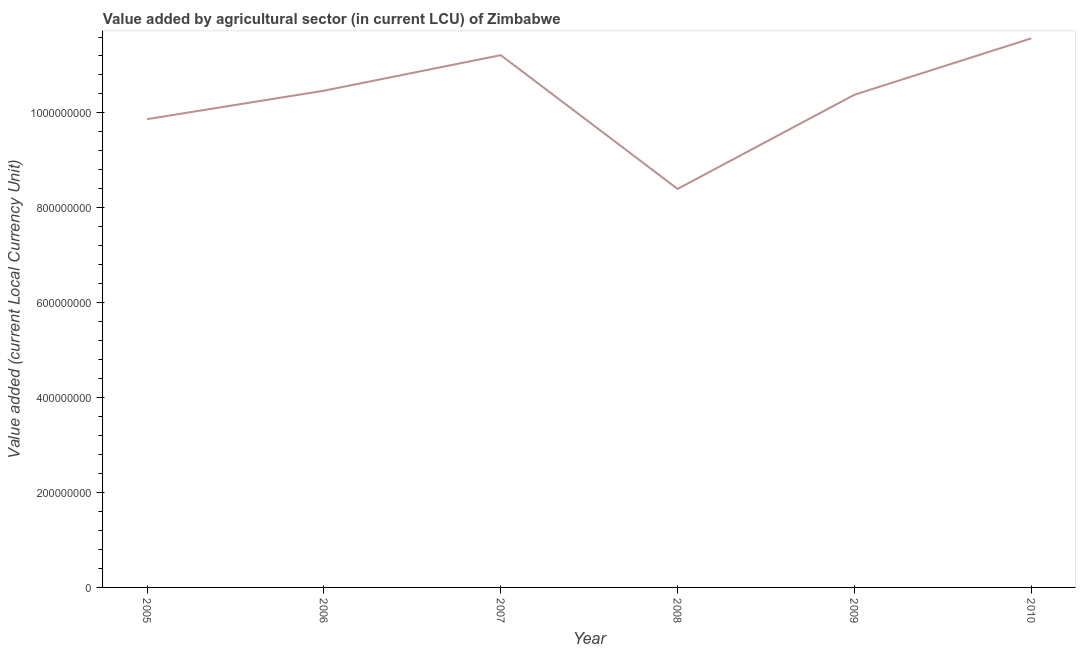What is the value added by agriculture sector in 2005?
Provide a short and direct response. 9.87e+08. Across all years, what is the maximum value added by agriculture sector?
Ensure brevity in your answer.  1.16e+09. Across all years, what is the minimum value added by agriculture sector?
Give a very brief answer. 8.40e+08. What is the sum of the value added by agriculture sector?
Provide a succinct answer. 6.19e+09. What is the difference between the value added by agriculture sector in 2005 and 2006?
Provide a short and direct response. -5.99e+07. What is the average value added by agriculture sector per year?
Keep it short and to the point. 1.03e+09. What is the median value added by agriculture sector?
Provide a succinct answer. 1.04e+09. What is the ratio of the value added by agriculture sector in 2005 to that in 2006?
Offer a terse response. 0.94. Is the value added by agriculture sector in 2006 less than that in 2007?
Make the answer very short. Yes. What is the difference between the highest and the second highest value added by agriculture sector?
Give a very brief answer. 3.54e+07. Is the sum of the value added by agriculture sector in 2005 and 2009 greater than the maximum value added by agriculture sector across all years?
Provide a short and direct response. Yes. What is the difference between the highest and the lowest value added by agriculture sector?
Offer a terse response. 3.17e+08. Does the value added by agriculture sector monotonically increase over the years?
Your answer should be very brief. No. How many lines are there?
Provide a short and direct response. 1. How many years are there in the graph?
Offer a terse response. 6. What is the difference between two consecutive major ticks on the Y-axis?
Keep it short and to the point. 2.00e+08. Does the graph contain grids?
Make the answer very short. No. What is the title of the graph?
Offer a very short reply. Value added by agricultural sector (in current LCU) of Zimbabwe. What is the label or title of the Y-axis?
Give a very brief answer. Value added (current Local Currency Unit). What is the Value added (current Local Currency Unit) in 2005?
Provide a short and direct response. 9.87e+08. What is the Value added (current Local Currency Unit) of 2006?
Your response must be concise. 1.05e+09. What is the Value added (current Local Currency Unit) in 2007?
Your answer should be compact. 1.12e+09. What is the Value added (current Local Currency Unit) in 2008?
Keep it short and to the point. 8.40e+08. What is the Value added (current Local Currency Unit) in 2009?
Offer a terse response. 1.04e+09. What is the Value added (current Local Currency Unit) of 2010?
Make the answer very short. 1.16e+09. What is the difference between the Value added (current Local Currency Unit) in 2005 and 2006?
Make the answer very short. -5.99e+07. What is the difference between the Value added (current Local Currency Unit) in 2005 and 2007?
Keep it short and to the point. -1.35e+08. What is the difference between the Value added (current Local Currency Unit) in 2005 and 2008?
Provide a short and direct response. 1.47e+08. What is the difference between the Value added (current Local Currency Unit) in 2005 and 2009?
Keep it short and to the point. -5.14e+07. What is the difference between the Value added (current Local Currency Unit) in 2005 and 2010?
Your answer should be compact. -1.70e+08. What is the difference between the Value added (current Local Currency Unit) in 2006 and 2007?
Your response must be concise. -7.49e+07. What is the difference between the Value added (current Local Currency Unit) in 2006 and 2008?
Provide a short and direct response. 2.07e+08. What is the difference between the Value added (current Local Currency Unit) in 2006 and 2009?
Ensure brevity in your answer.  8.51e+06. What is the difference between the Value added (current Local Currency Unit) in 2006 and 2010?
Your answer should be compact. -1.10e+08. What is the difference between the Value added (current Local Currency Unit) in 2007 and 2008?
Make the answer very short. 2.82e+08. What is the difference between the Value added (current Local Currency Unit) in 2007 and 2009?
Make the answer very short. 8.34e+07. What is the difference between the Value added (current Local Currency Unit) in 2007 and 2010?
Your answer should be compact. -3.54e+07. What is the difference between the Value added (current Local Currency Unit) in 2008 and 2009?
Provide a succinct answer. -1.98e+08. What is the difference between the Value added (current Local Currency Unit) in 2008 and 2010?
Make the answer very short. -3.17e+08. What is the difference between the Value added (current Local Currency Unit) in 2009 and 2010?
Give a very brief answer. -1.19e+08. What is the ratio of the Value added (current Local Currency Unit) in 2005 to that in 2006?
Your response must be concise. 0.94. What is the ratio of the Value added (current Local Currency Unit) in 2005 to that in 2008?
Make the answer very short. 1.18. What is the ratio of the Value added (current Local Currency Unit) in 2005 to that in 2009?
Offer a very short reply. 0.95. What is the ratio of the Value added (current Local Currency Unit) in 2005 to that in 2010?
Make the answer very short. 0.85. What is the ratio of the Value added (current Local Currency Unit) in 2006 to that in 2007?
Ensure brevity in your answer.  0.93. What is the ratio of the Value added (current Local Currency Unit) in 2006 to that in 2008?
Offer a very short reply. 1.25. What is the ratio of the Value added (current Local Currency Unit) in 2006 to that in 2009?
Your answer should be compact. 1.01. What is the ratio of the Value added (current Local Currency Unit) in 2006 to that in 2010?
Provide a short and direct response. 0.91. What is the ratio of the Value added (current Local Currency Unit) in 2007 to that in 2008?
Your response must be concise. 1.34. What is the ratio of the Value added (current Local Currency Unit) in 2007 to that in 2009?
Offer a terse response. 1.08. What is the ratio of the Value added (current Local Currency Unit) in 2007 to that in 2010?
Your answer should be very brief. 0.97. What is the ratio of the Value added (current Local Currency Unit) in 2008 to that in 2009?
Offer a very short reply. 0.81. What is the ratio of the Value added (current Local Currency Unit) in 2008 to that in 2010?
Ensure brevity in your answer.  0.73. What is the ratio of the Value added (current Local Currency Unit) in 2009 to that in 2010?
Offer a terse response. 0.9. 